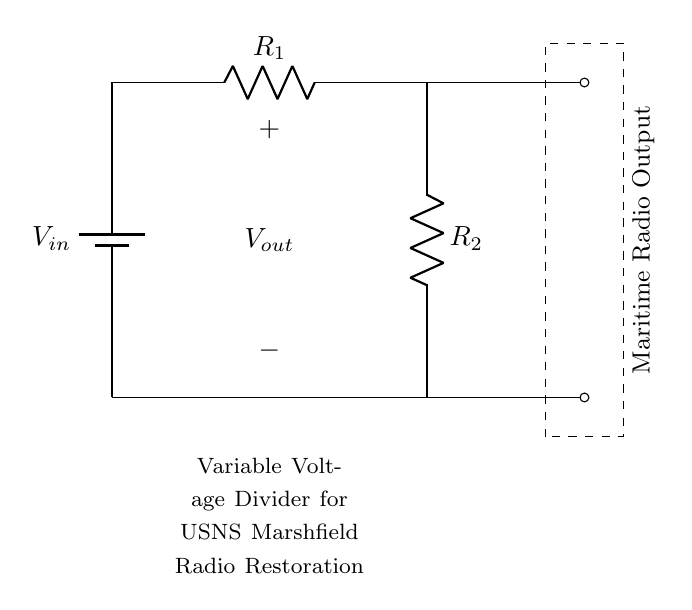What is the input voltage? The input voltage is identified as \( V_{in} \) in the circuit diagram, indicated by the battery symbol at the left side.
Answer: \( V_{in} \) What are the resistors in this circuit? There are two resistors in the circuit, labeled as \( R_1 \) and \( R_2 \), which are arranged in series between the input voltage and ground.
Answer: \( R_1, R_2 \) What is the output voltage labeled as? The output voltage is labeled as \( V_{out} \) in the circuit and is placed vertically between the two resistors.
Answer: \( V_{out} \) What is the purpose of this circuit? The purpose of this circuit is to create a variable voltage output, specifically for radio restoration applications, as stated in the note below the circuit.
Answer: Variable voltage output How is the output voltage \( V_{out} \) related to \( V_{in} \)? The output voltage \( V_{out} \) can be determined using the voltage divider formula \( V_{out} = \frac{R_2}{R_1 + R_2} \times V_{in} \), which shows how \( V_{in} \) is divided across the resistors.
Answer: Voltage divider formula What does the dashed rectangle signify? The dashed rectangle signifies the section for the maritime radio output, indicating where the variable voltage can be taken for use in radio equipment.
Answer: Maritime Radio Output How is the current flow in this circuit? The current flows from the positive terminal of the battery (input voltage) through \( R_1 \) and \( R_2 \) to ground, following the path defined by the series connection of the resistors.
Answer: From \( V_{in} \) to ground 